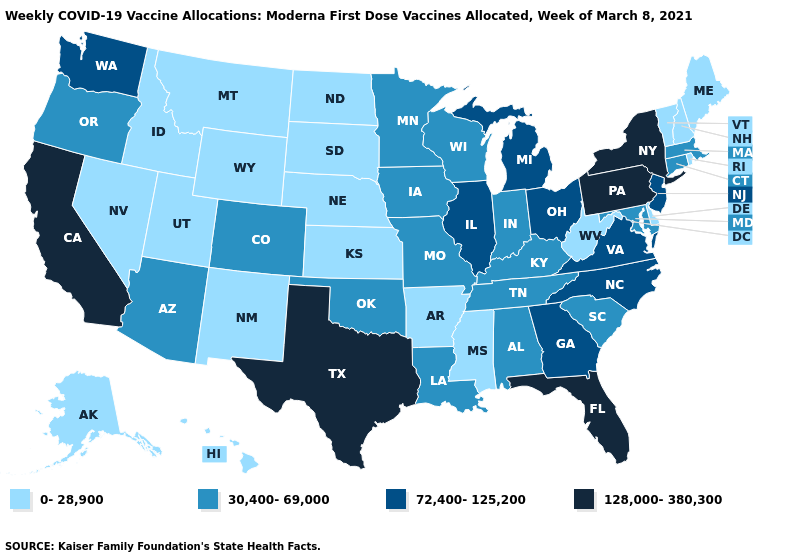What is the lowest value in states that border Louisiana?
Concise answer only. 0-28,900. What is the value of Utah?
Be succinct. 0-28,900. What is the value of Maryland?
Give a very brief answer. 30,400-69,000. Name the states that have a value in the range 72,400-125,200?
Be succinct. Georgia, Illinois, Michigan, New Jersey, North Carolina, Ohio, Virginia, Washington. Does New Hampshire have a lower value than Nebraska?
Be succinct. No. Name the states that have a value in the range 128,000-380,300?
Be succinct. California, Florida, New York, Pennsylvania, Texas. What is the value of Idaho?
Concise answer only. 0-28,900. Does Michigan have the same value as Wyoming?
Give a very brief answer. No. Name the states that have a value in the range 0-28,900?
Keep it brief. Alaska, Arkansas, Delaware, Hawaii, Idaho, Kansas, Maine, Mississippi, Montana, Nebraska, Nevada, New Hampshire, New Mexico, North Dakota, Rhode Island, South Dakota, Utah, Vermont, West Virginia, Wyoming. Does Minnesota have the highest value in the USA?
Answer briefly. No. Does Arizona have a higher value than Mississippi?
Quick response, please. Yes. Which states hav the highest value in the West?
Short answer required. California. Name the states that have a value in the range 30,400-69,000?
Answer briefly. Alabama, Arizona, Colorado, Connecticut, Indiana, Iowa, Kentucky, Louisiana, Maryland, Massachusetts, Minnesota, Missouri, Oklahoma, Oregon, South Carolina, Tennessee, Wisconsin. Which states have the lowest value in the USA?
Short answer required. Alaska, Arkansas, Delaware, Hawaii, Idaho, Kansas, Maine, Mississippi, Montana, Nebraska, Nevada, New Hampshire, New Mexico, North Dakota, Rhode Island, South Dakota, Utah, Vermont, West Virginia, Wyoming. What is the value of Indiana?
Quick response, please. 30,400-69,000. 